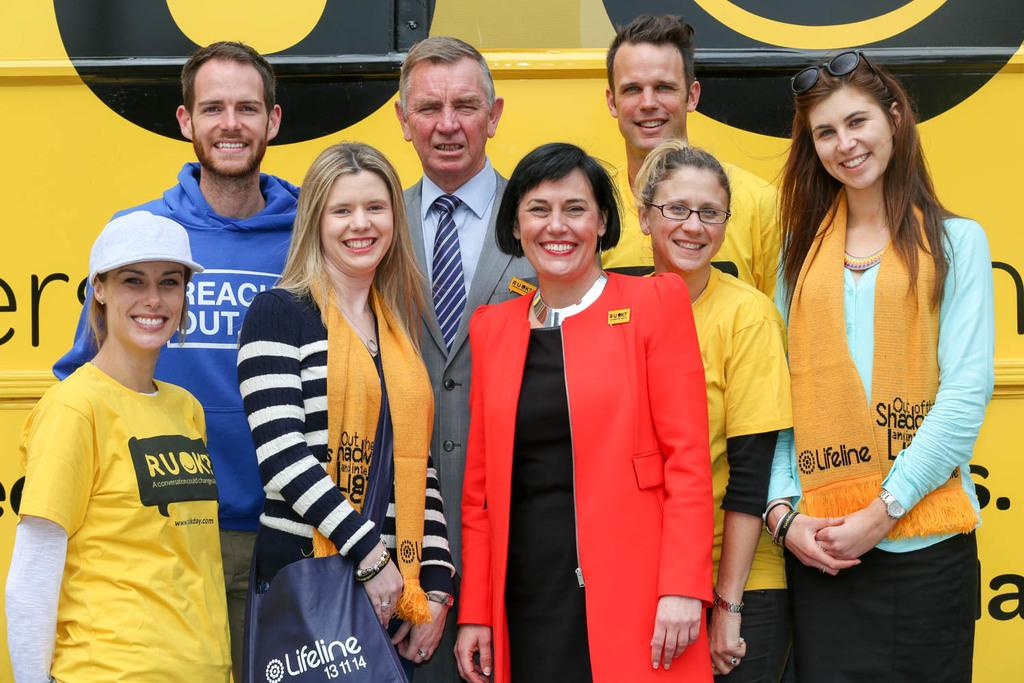Provide a one-sentence caption for the provided image. A group of people supporting Ru Ok, a conversation could change all. 